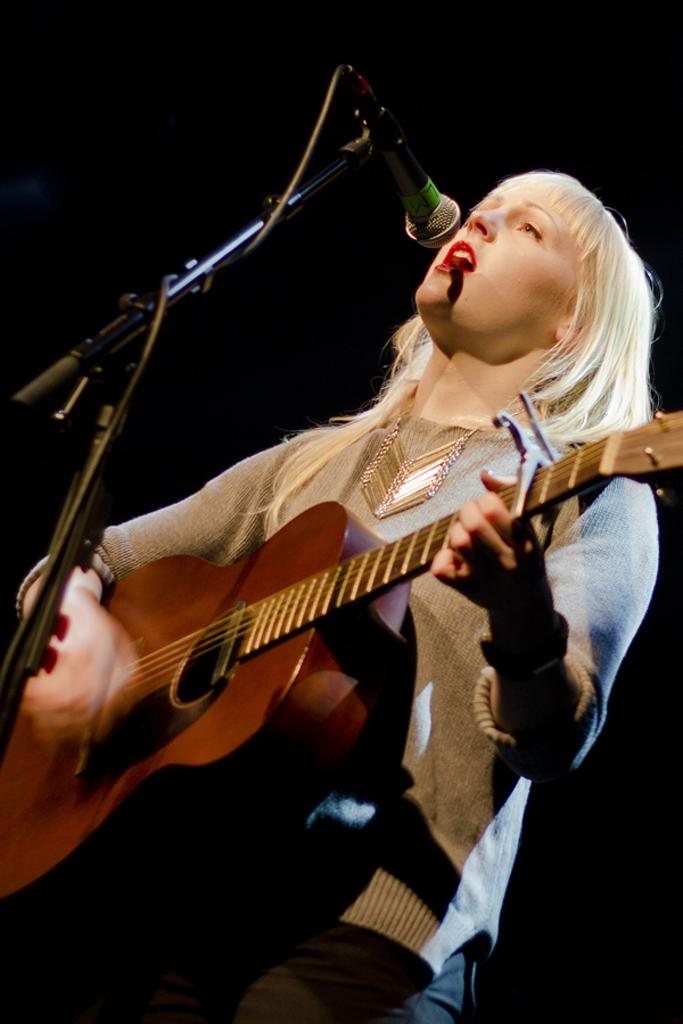Who is the main subject in the image? There is a woman in the image. Where is the woman positioned in the image? The woman is standing at the center. What is the woman doing in the image? The woman is playing a guitar and singing. What can be seen on the left side of the image? There is a stand on the left side of the image, and a microphone is attached to the stand. What is the color of the background in the image? The background of the image is dark. What type of parcel is the woman holding in the image? There is no parcel present in the image; the woman is playing a guitar and singing. 